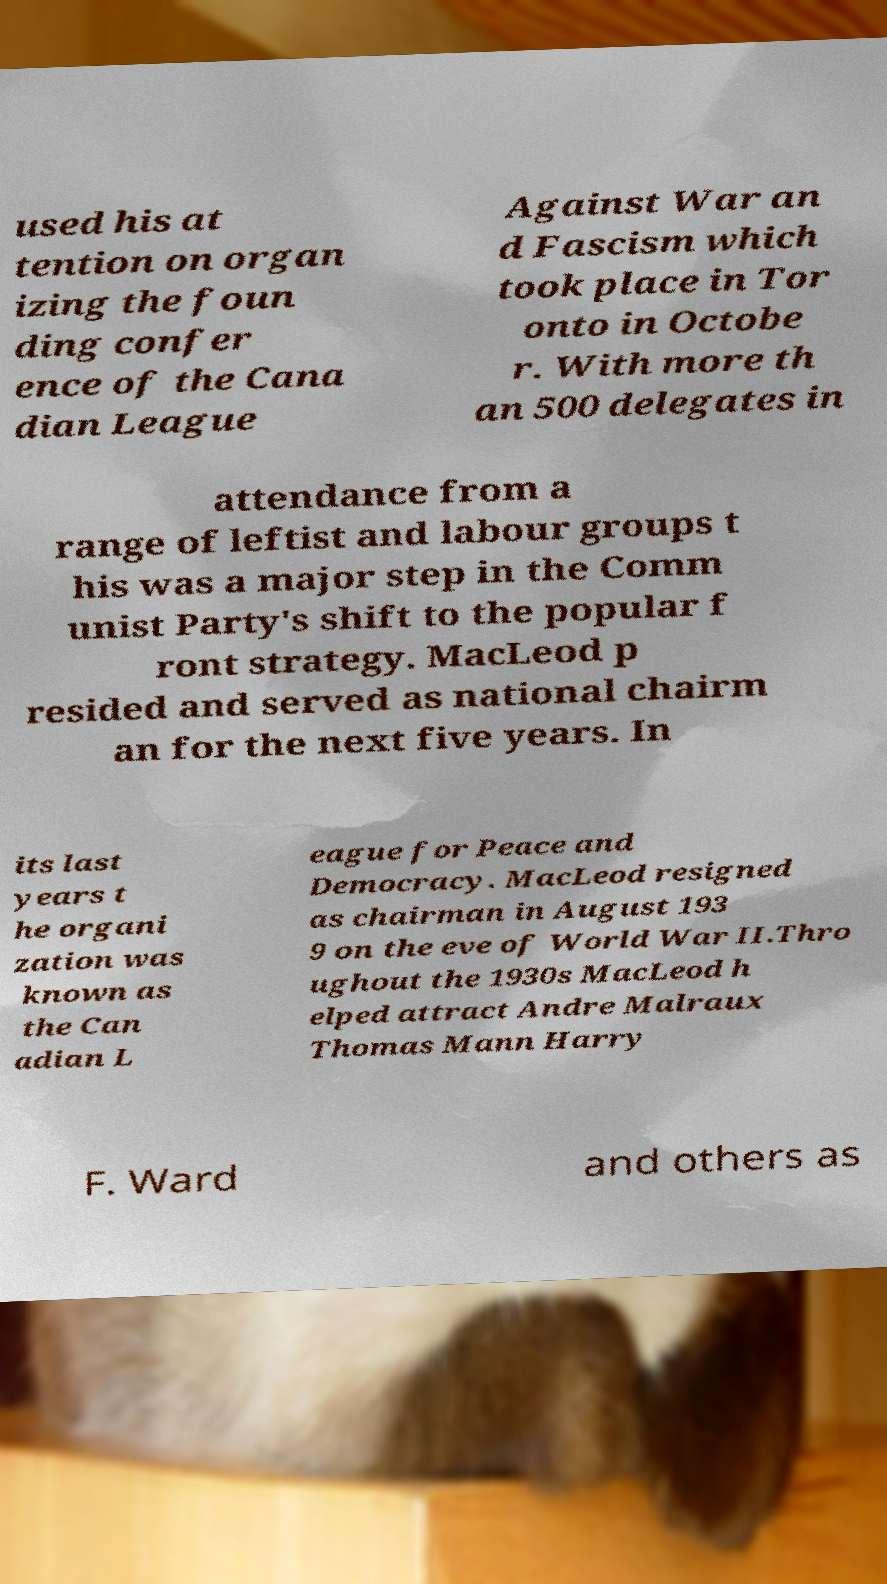What messages or text are displayed in this image? I need them in a readable, typed format. used his at tention on organ izing the foun ding confer ence of the Cana dian League Against War an d Fascism which took place in Tor onto in Octobe r. With more th an 500 delegates in attendance from a range of leftist and labour groups t his was a major step in the Comm unist Party's shift to the popular f ront strategy. MacLeod p resided and served as national chairm an for the next five years. In its last years t he organi zation was known as the Can adian L eague for Peace and Democracy. MacLeod resigned as chairman in August 193 9 on the eve of World War II.Thro ughout the 1930s MacLeod h elped attract Andre Malraux Thomas Mann Harry F. Ward and others as 